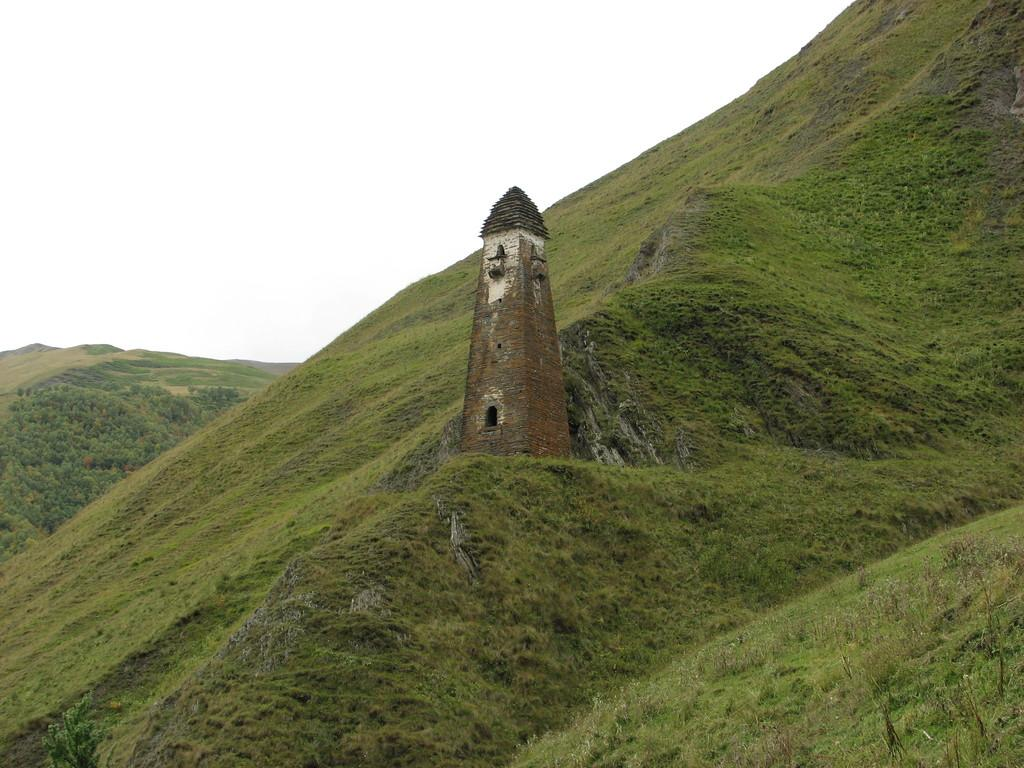What type of structure is present in the image? There is a building in the image. What natural features can be seen in the image? There are hills and trees in the image. What is the ground covered with in the image? The ground is covered with grass in the image. What is visible in the background of the image? The sky is visible in the background of the image. What type of animal can be heard making noise in the image? There is no animal present in the image, and therefore no noise can be heard. What type of drink is being served in the image? There is no drink present in the image. 